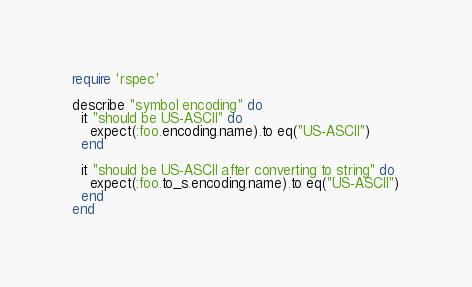<code> <loc_0><loc_0><loc_500><loc_500><_Ruby_>require 'rspec'

describe "symbol encoding" do
  it "should be US-ASCII" do
    expect(:foo.encoding.name).to eq("US-ASCII")
  end

  it "should be US-ASCII after converting to string" do
    expect(:foo.to_s.encoding.name).to eq("US-ASCII")
  end
end
</code> 